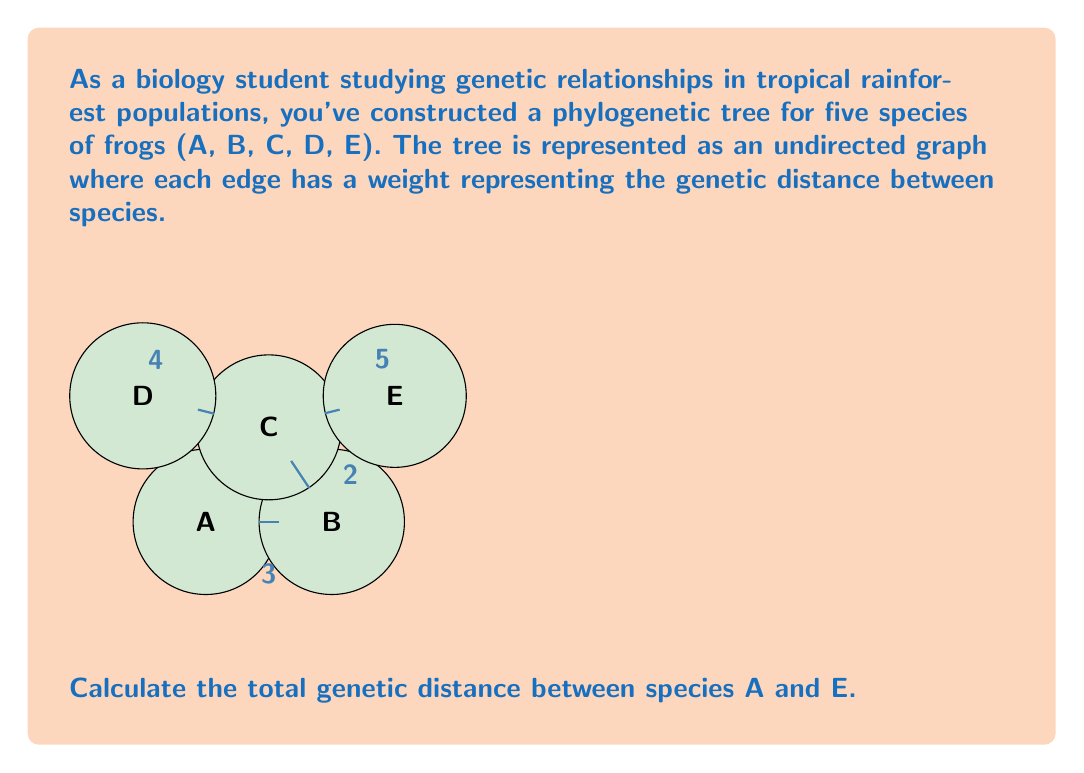Can you solve this math problem? To find the total genetic distance between species A and E, we need to sum the weights of the edges along the path connecting these two species. Let's break it down step-by-step:

1. Identify the path from A to E:
   A → B → C → E

2. Sum the weights along this path:
   - A to B: 3
   - B to C: 2
   - C to E: 5

3. Calculate the total distance:
   $$\text{Total distance} = 3 + 2 + 5 = 10$$

The total genetic distance between species A and E is 10 units.

This method of calculating distances in a phylogenetic tree is crucial for understanding evolutionary relationships. The larger the genetic distance, the more evolutionarily distant the species are from each other.
Answer: 10 